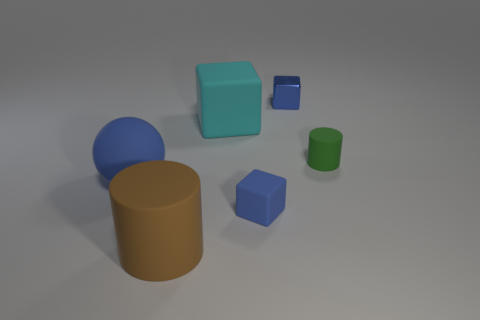Subtract all small blocks. How many blocks are left? 1 Add 1 tiny cylinders. How many tiny cylinders are left? 2 Add 1 blue matte things. How many blue matte things exist? 3 Add 2 large balls. How many objects exist? 8 Subtract all cyan cubes. How many cubes are left? 2 Subtract 0 brown blocks. How many objects are left? 6 Subtract all cylinders. How many objects are left? 4 Subtract 3 cubes. How many cubes are left? 0 Subtract all gray cylinders. Subtract all brown cubes. How many cylinders are left? 2 Subtract all blue blocks. How many brown cylinders are left? 1 